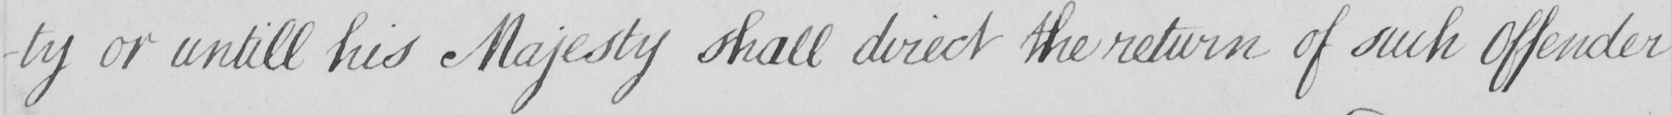What text is written in this handwritten line? -ty or untill his Majesty shall direct the return of such Offender 